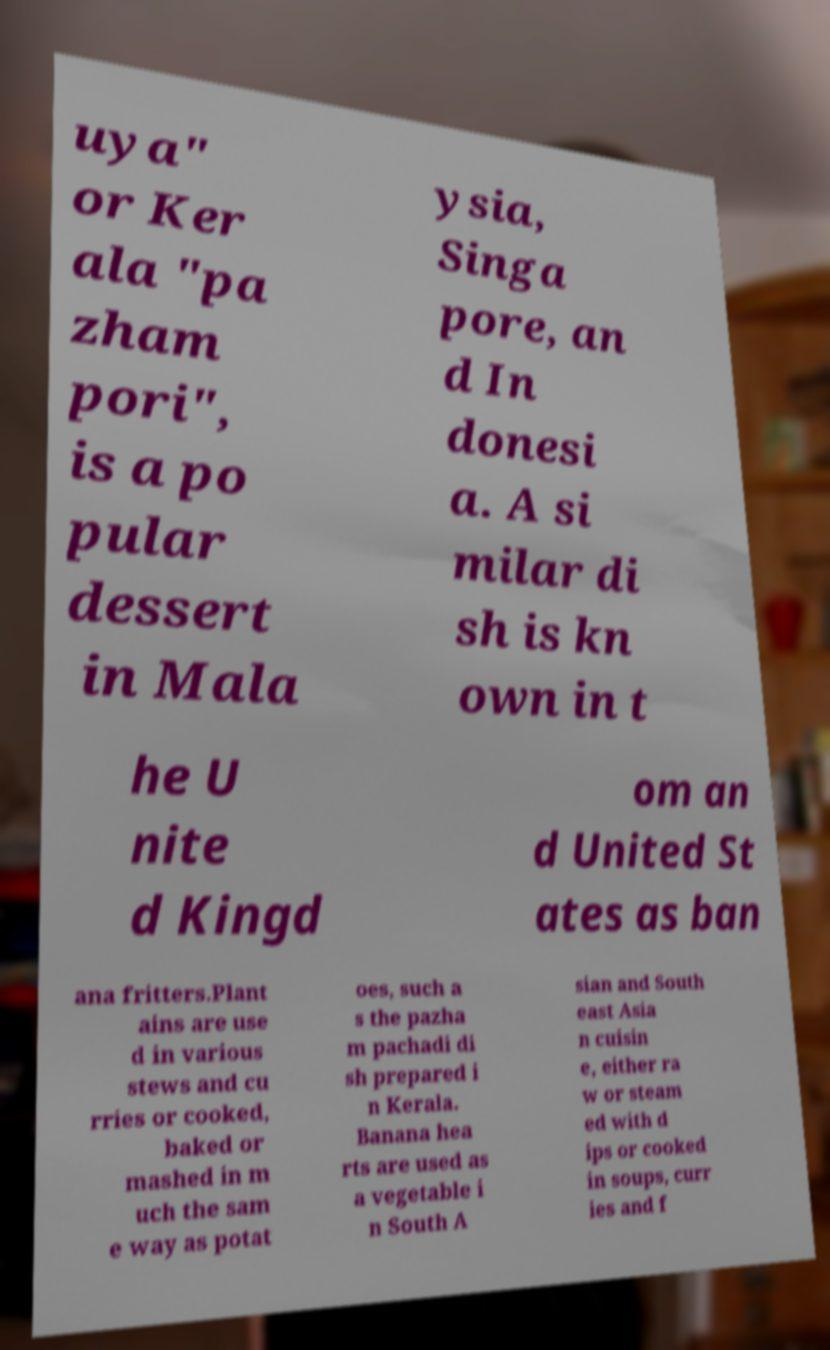For documentation purposes, I need the text within this image transcribed. Could you provide that? uya" or Ker ala "pa zham pori", is a po pular dessert in Mala ysia, Singa pore, an d In donesi a. A si milar di sh is kn own in t he U nite d Kingd om an d United St ates as ban ana fritters.Plant ains are use d in various stews and cu rries or cooked, baked or mashed in m uch the sam e way as potat oes, such a s the pazha m pachadi di sh prepared i n Kerala. Banana hea rts are used as a vegetable i n South A sian and South east Asia n cuisin e, either ra w or steam ed with d ips or cooked in soups, curr ies and f 